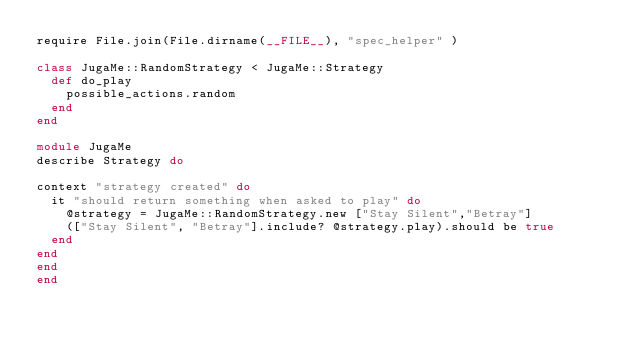Convert code to text. <code><loc_0><loc_0><loc_500><loc_500><_Ruby_>require File.join(File.dirname(__FILE__), "spec_helper" )

class JugaMe::RandomStrategy < JugaMe::Strategy
  def do_play
    possible_actions.random
  end
end

module JugaMe
describe Strategy do

context "strategy created" do
  it "should return something when asked to play" do
    @strategy = JugaMe::RandomStrategy.new ["Stay Silent","Betray"]
    (["Stay Silent", "Betray"].include? @strategy.play).should be true
  end
end
end
end
</code> 